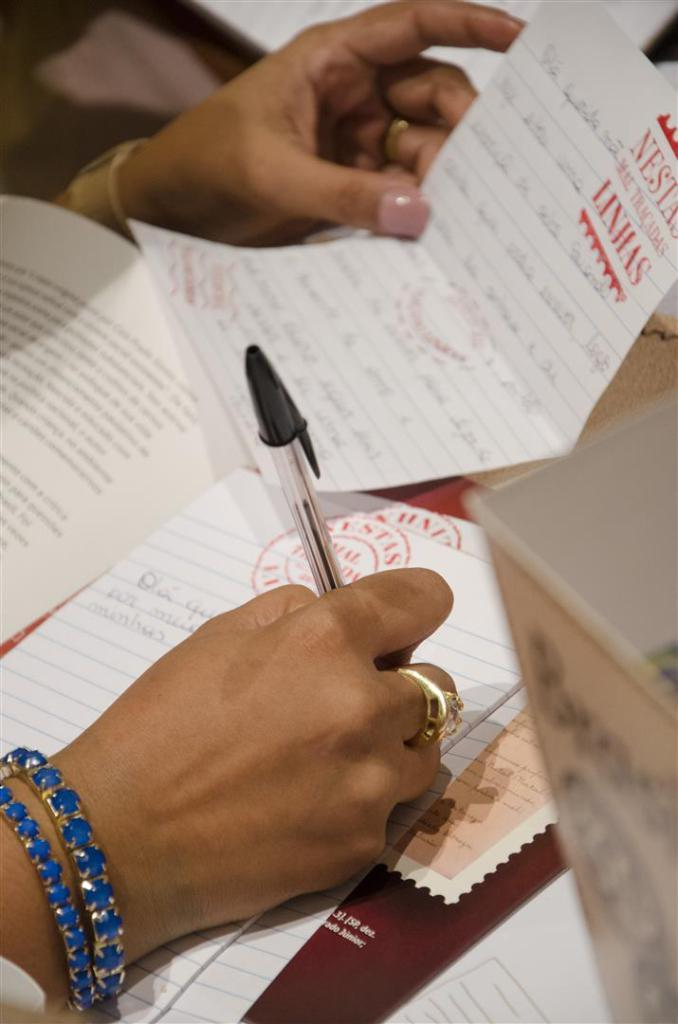Who is the main subject in the picture? There is a woman in the picture. What is the woman doing in the image? The woman is writing with one hand and holding a paper in her other hand. What else can be seen in the image besides the woman? There are papers with text visible in the image. What type of rings can be seen on the woman's fingers in the image? There are no rings visible on the woman's fingers in the image. What is the humorous aspect of the image? The image does not appear to have a humorous aspect; it simply shows a woman writing and holding a paper. 